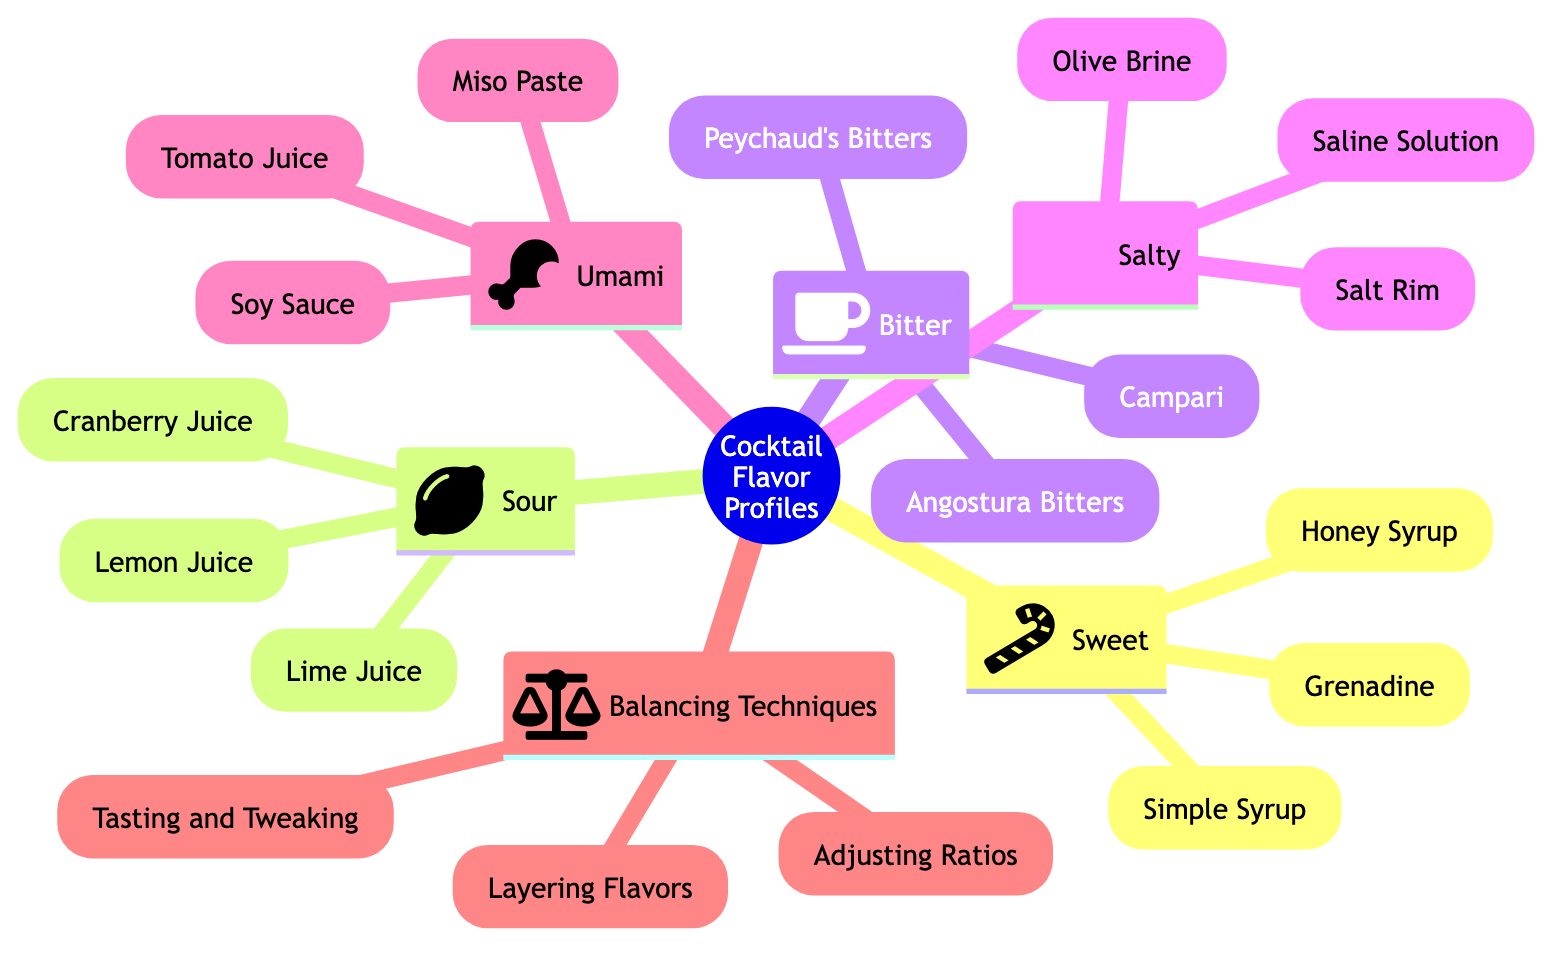What are the three ingredients listed under Sweet? The ingredients under Sweet are Simple Syrup, Grenadine, and Honey Syrup, which can be found in the respective section of the diagram.
Answer: Simple Syrup, Grenadine, Honey Syrup How many flavor profiles are shown in the diagram? The diagram lists five flavor profiles: Sweet, Sour, Bitter, Salty, and Umami, counting them results in five total.
Answer: Five Which flavor profile includes Angostura Bitters? Angostura Bitters is listed under the Bitter flavor profile, as indicated in the diagram.
Answer: Bitter What balancing technique involves modifying ingredient proportions? The strategy for modifying ingredient proportions is referred to as Adjusting Ratios, which can be found under the Balancing Techniques section.
Answer: Adjusting Ratios What is the main source of Honey Syrup? Honey Syrup's main source is Honey, which is mentioned in the description of the ingredient within the Sweet section.
Answer: Honey Which two flavors are represented with an icon of a lemon? The flavors represented with a lemon icon are Lemon Juice and Lime Juice, found in the Sour section of the diagram.
Answer: Lemon Juice, Lime Juice What savory ingredient is used in Bloody Marys? The savory ingredient used in Bloody Marys is Tomato Juice, which is located in the Umami section of the diagram.
Answer: Tomato Juice What strategy suggests tasting and adjusting during cocktail preparation? The strategy that suggests tasting and adjusting is Tasting and Tweaking, which is detailed under Balancing Techniques.
Answer: Tasting and Tweaking Which ingredient is derived from fermented soybeans? Soy Sauce and Miso Paste are both derived from fermented soybeans, as seen in the Umami section where these ingredients are listed.
Answer: Soy Sauce, Miso Paste 